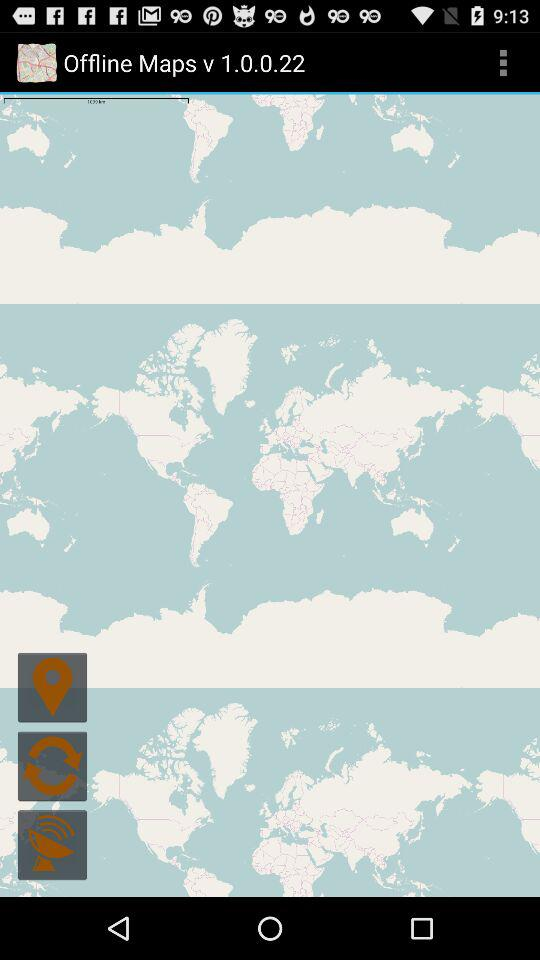Which version of "Offline Maps" is used? The used version is v 1.0.0.22. 